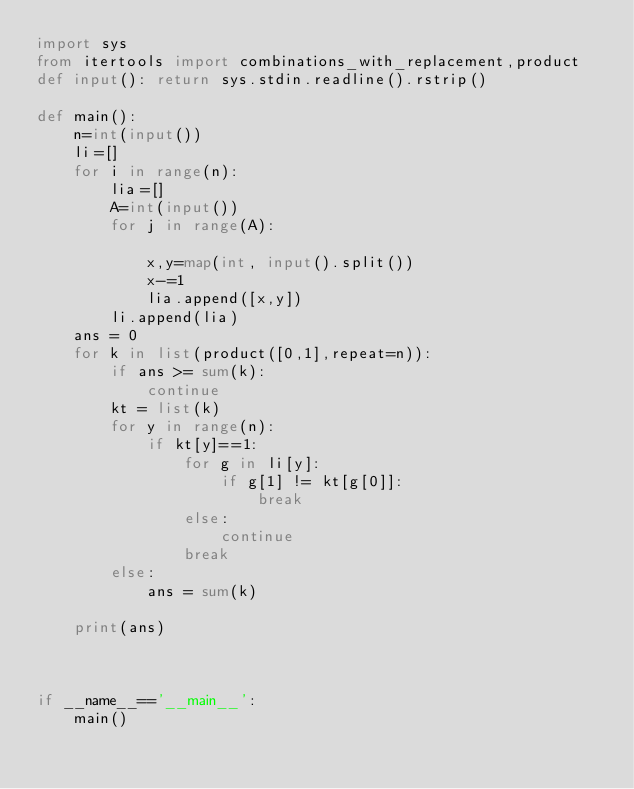Convert code to text. <code><loc_0><loc_0><loc_500><loc_500><_Python_>import sys
from itertools import combinations_with_replacement,product
def input(): return sys.stdin.readline().rstrip()
 
def main():
    n=int(input())
    li=[]
    for i in range(n):
        lia=[]
        A=int(input())
        for j in range(A):

            x,y=map(int, input().split())
            x-=1
            lia.append([x,y])
        li.append(lia)
    ans = 0
    for k in list(product([0,1],repeat=n)):
        if ans >= sum(k):
            continue
        kt = list(k)
        for y in range(n):
            if kt[y]==1:
                for g in li[y]:
                    if g[1] != kt[g[0]]:
                        break
                else:
                    continue
                break
        else:
            ans = sum(k)
            
    print(ans)



if __name__=='__main__':
    main()</code> 